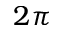<formula> <loc_0><loc_0><loc_500><loc_500>2 \pi</formula> 